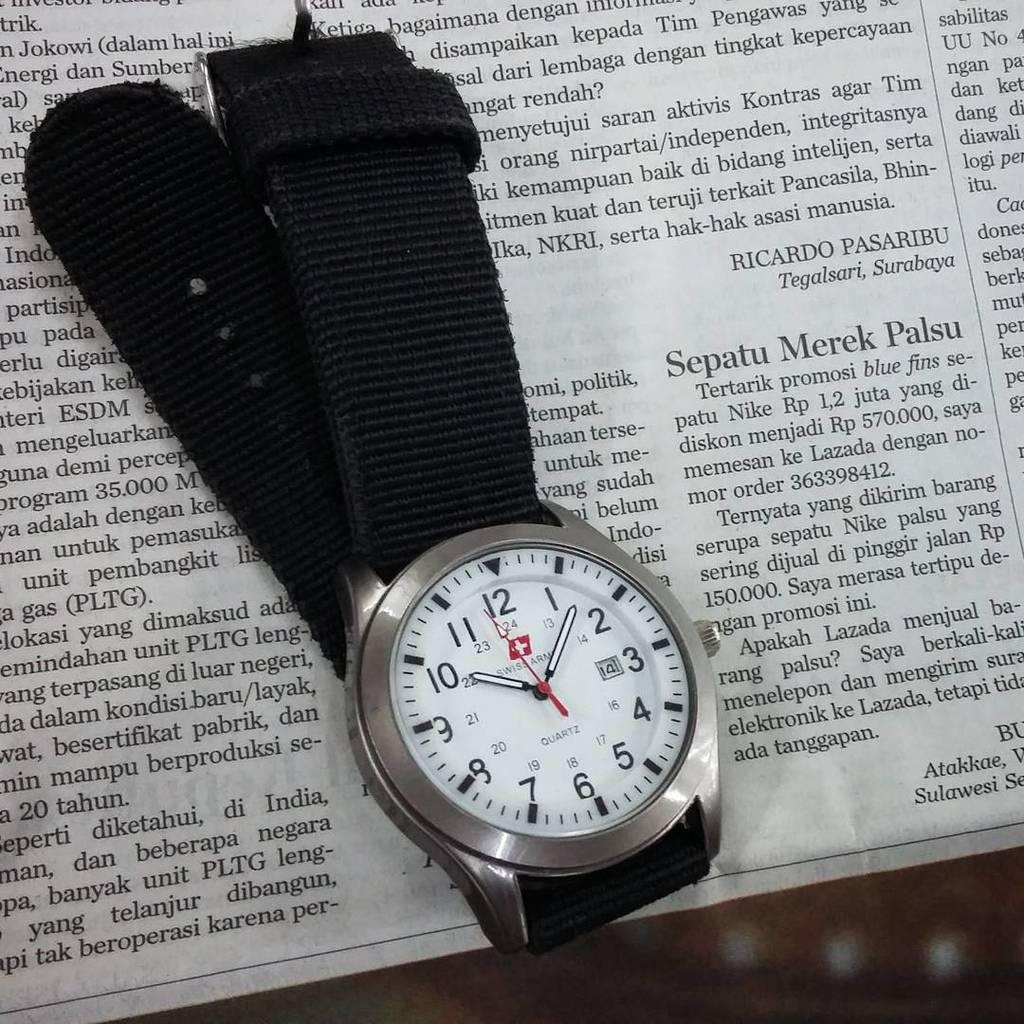<image>
Render a clear and concise summary of the photo. A Swiss Army quartz watch is lying across a newspaper. 